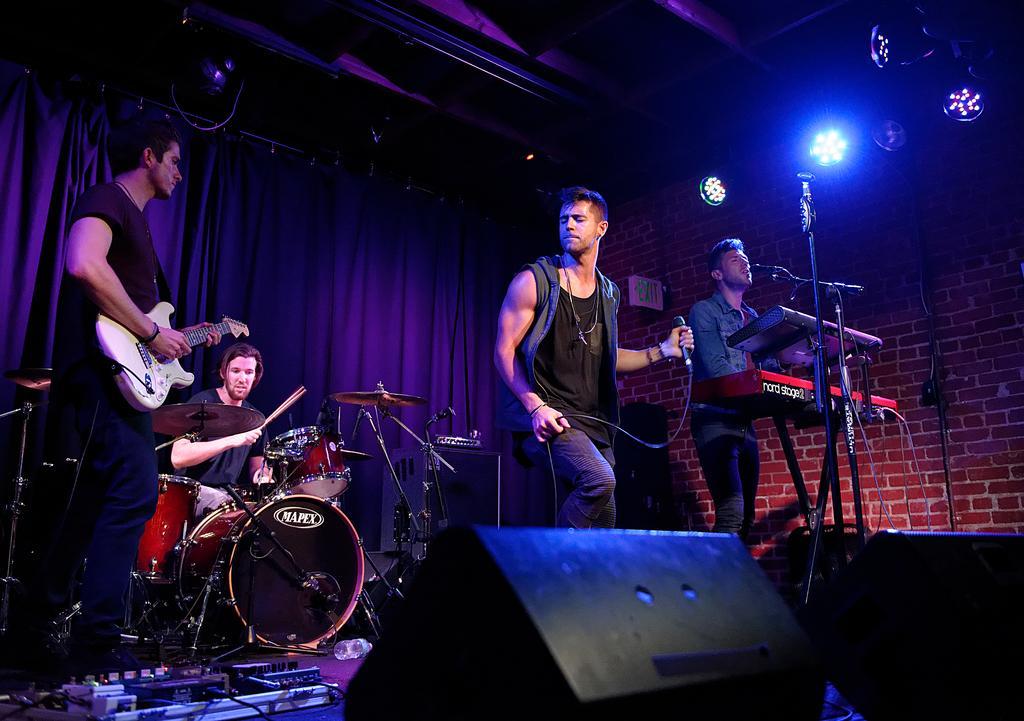How would you summarize this image in a sentence or two? In this picture we can see four persons playing musical instruments such as drums, guitar, piano and here person singing on mic and in background we can see curtains, light, wall. 